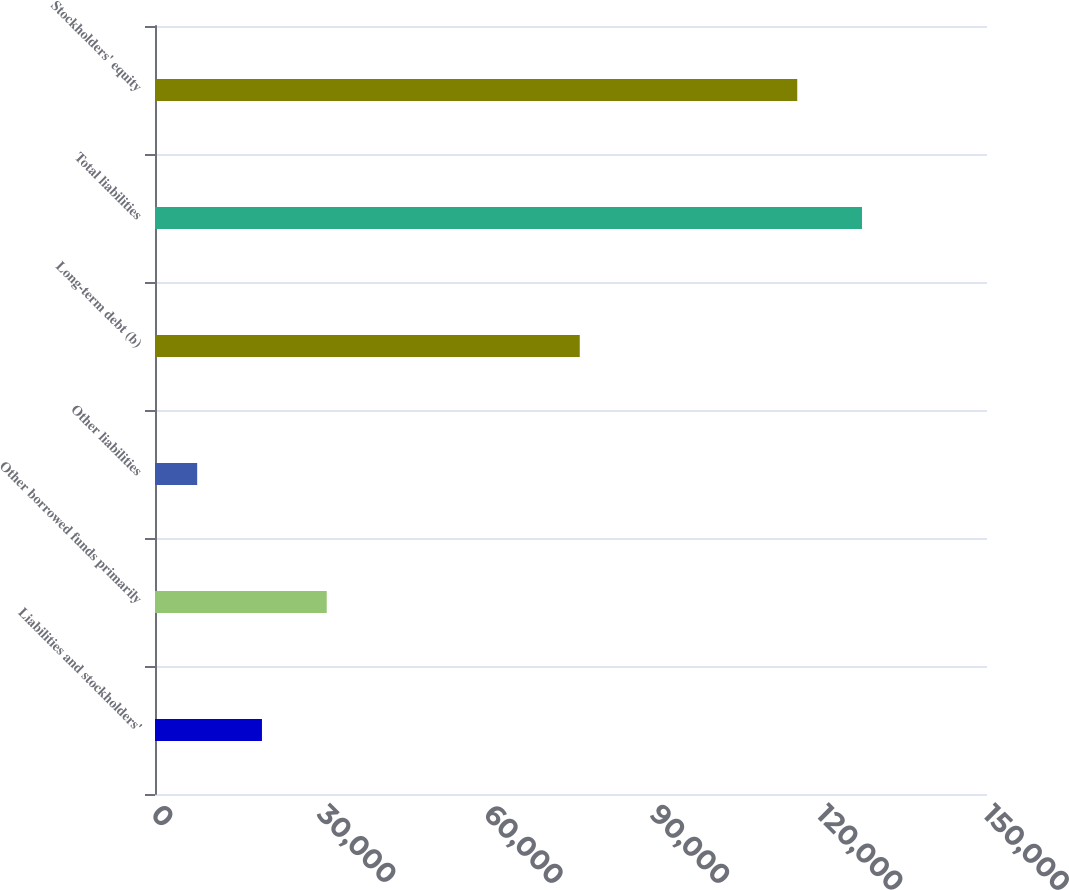Convert chart. <chart><loc_0><loc_0><loc_500><loc_500><bar_chart><fcel>Liabilities and stockholders'<fcel>Other borrowed funds primarily<fcel>Other liabilities<fcel>Long-term debt (b)<fcel>Total liabilities<fcel>Stockholders' equity<nl><fcel>19282.5<fcel>30960<fcel>7605<fcel>76581<fcel>127468<fcel>115790<nl></chart> 